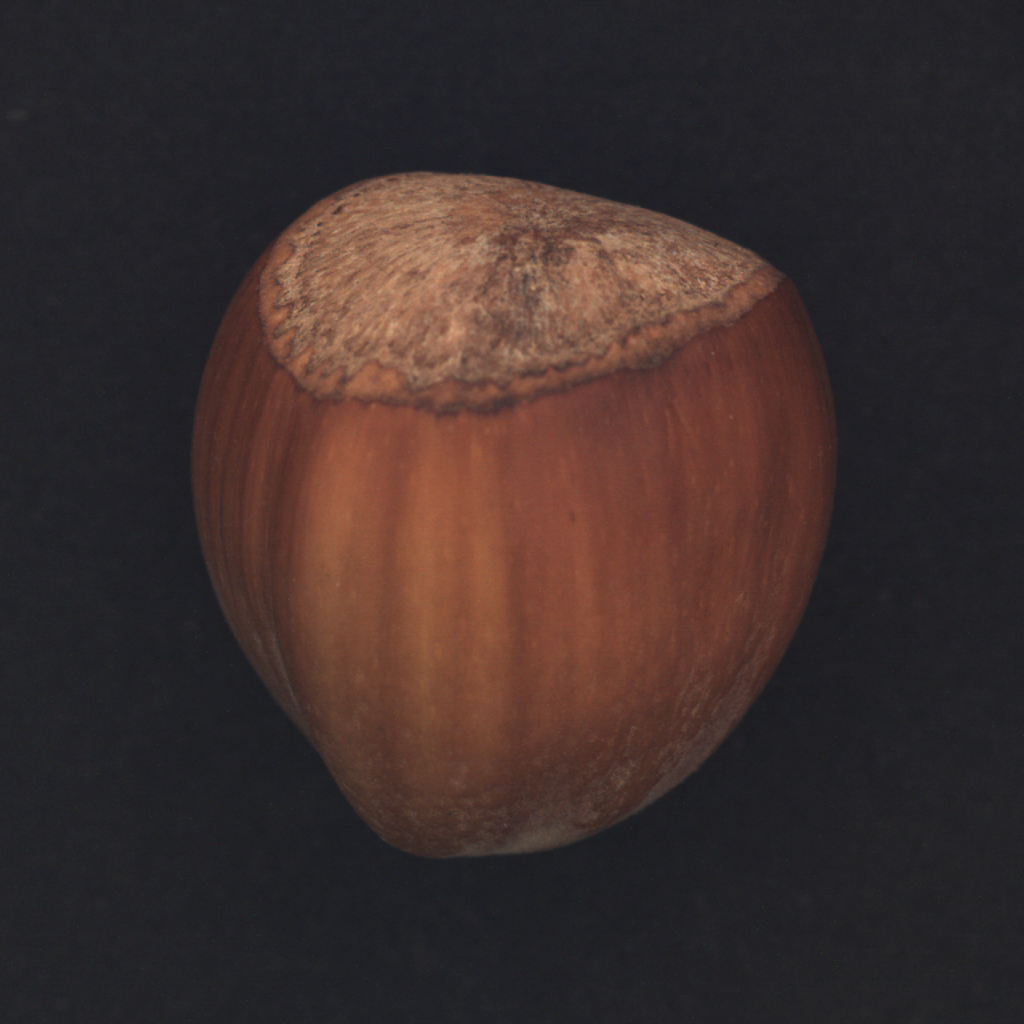Could you elaborate on why hazelnuts are often found with a rough fibrous cap in images? The rough, fibrous cap on hazelnuts is actually part of the fruit's natural protective husk. In botanical terms, this is known as the involucre, which surrounds the nut during its growth, offering physical protection from elements and pests. Visually, this husk adds a textured contrast to the relatively smooth shell of the nut, often depicted in images to signify naturalness and authenticity of the hazelnut. 